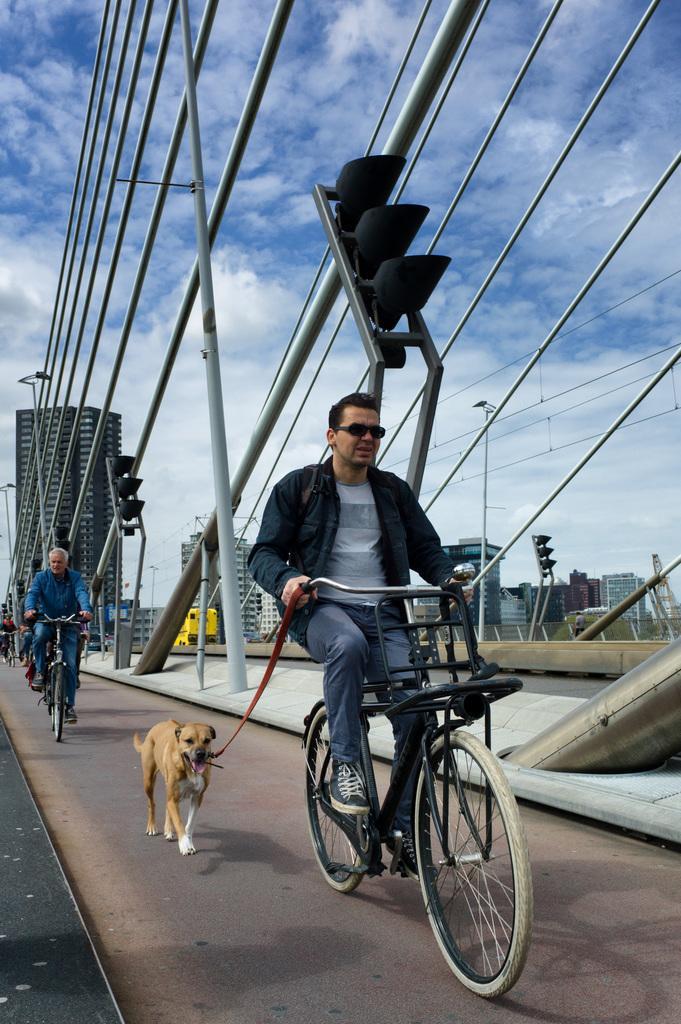Please provide a concise description of this image. there is a person riding bicycle, holding a belt of the dog. behind him there are other people riding bicycles. at the back there are buildings. 